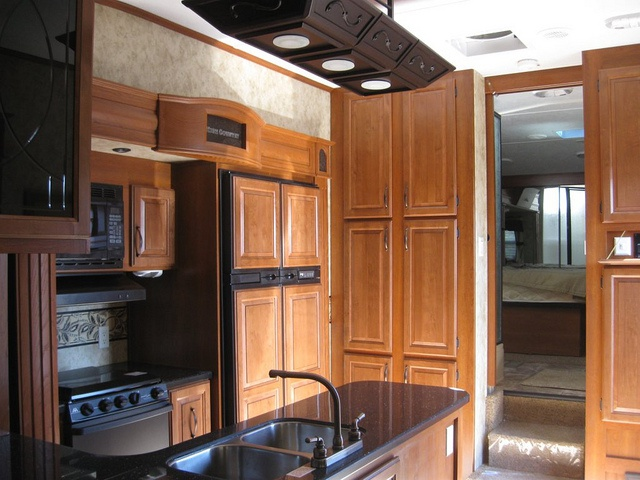Describe the objects in this image and their specific colors. I can see oven in black, gray, and darkblue tones, sink in black and gray tones, and microwave in black, gray, and darkblue tones in this image. 